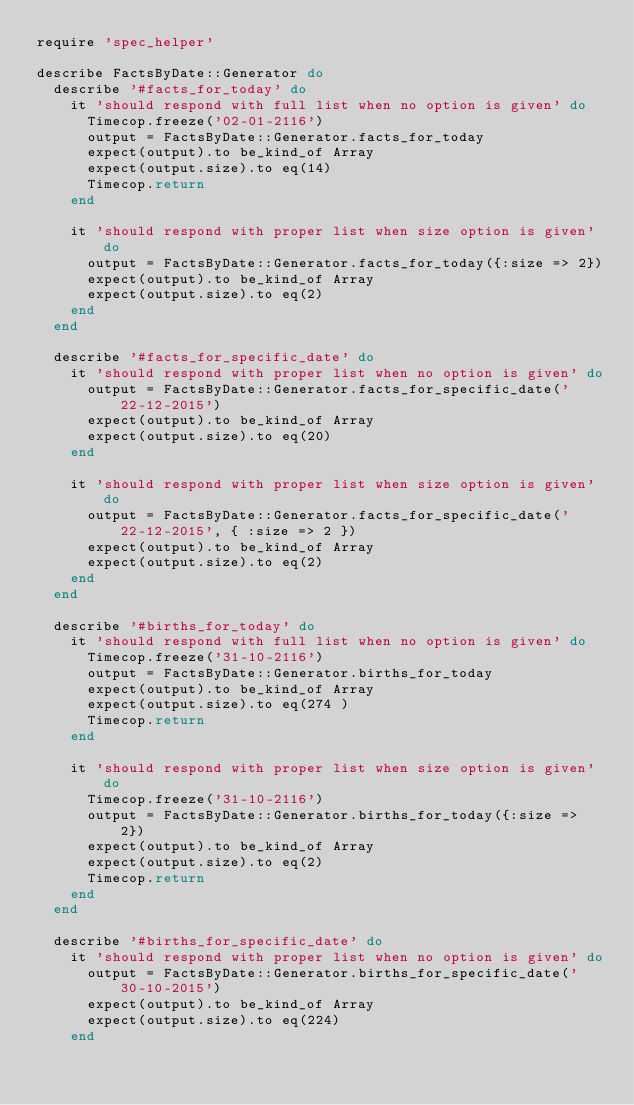<code> <loc_0><loc_0><loc_500><loc_500><_Ruby_>require 'spec_helper'

describe FactsByDate::Generator do
  describe '#facts_for_today' do
    it 'should respond with full list when no option is given' do
      Timecop.freeze('02-01-2116')
      output = FactsByDate::Generator.facts_for_today
      expect(output).to be_kind_of Array
      expect(output.size).to eq(14)
      Timecop.return
    end

    it 'should respond with proper list when size option is given' do
      output = FactsByDate::Generator.facts_for_today({:size => 2})
      expect(output).to be_kind_of Array
      expect(output.size).to eq(2)
    end
  end

  describe '#facts_for_specific_date' do
    it 'should respond with proper list when no option is given' do
      output = FactsByDate::Generator.facts_for_specific_date('22-12-2015')
      expect(output).to be_kind_of Array
      expect(output.size).to eq(20)
    end

    it 'should respond with proper list when size option is given' do
      output = FactsByDate::Generator.facts_for_specific_date('22-12-2015', { :size => 2 })
      expect(output).to be_kind_of Array
      expect(output.size).to eq(2)
    end
  end

  describe '#births_for_today' do
    it 'should respond with full list when no option is given' do
      Timecop.freeze('31-10-2116')
      output = FactsByDate::Generator.births_for_today
      expect(output).to be_kind_of Array
      expect(output.size).to eq(274 )
      Timecop.return
    end

    it 'should respond with proper list when size option is given' do
      Timecop.freeze('31-10-2116')
      output = FactsByDate::Generator.births_for_today({:size => 2})
      expect(output).to be_kind_of Array
      expect(output.size).to eq(2)
      Timecop.return
    end
  end

  describe '#births_for_specific_date' do
    it 'should respond with proper list when no option is given' do
      output = FactsByDate::Generator.births_for_specific_date('30-10-2015')
      expect(output).to be_kind_of Array
      expect(output.size).to eq(224)
    end
</code> 